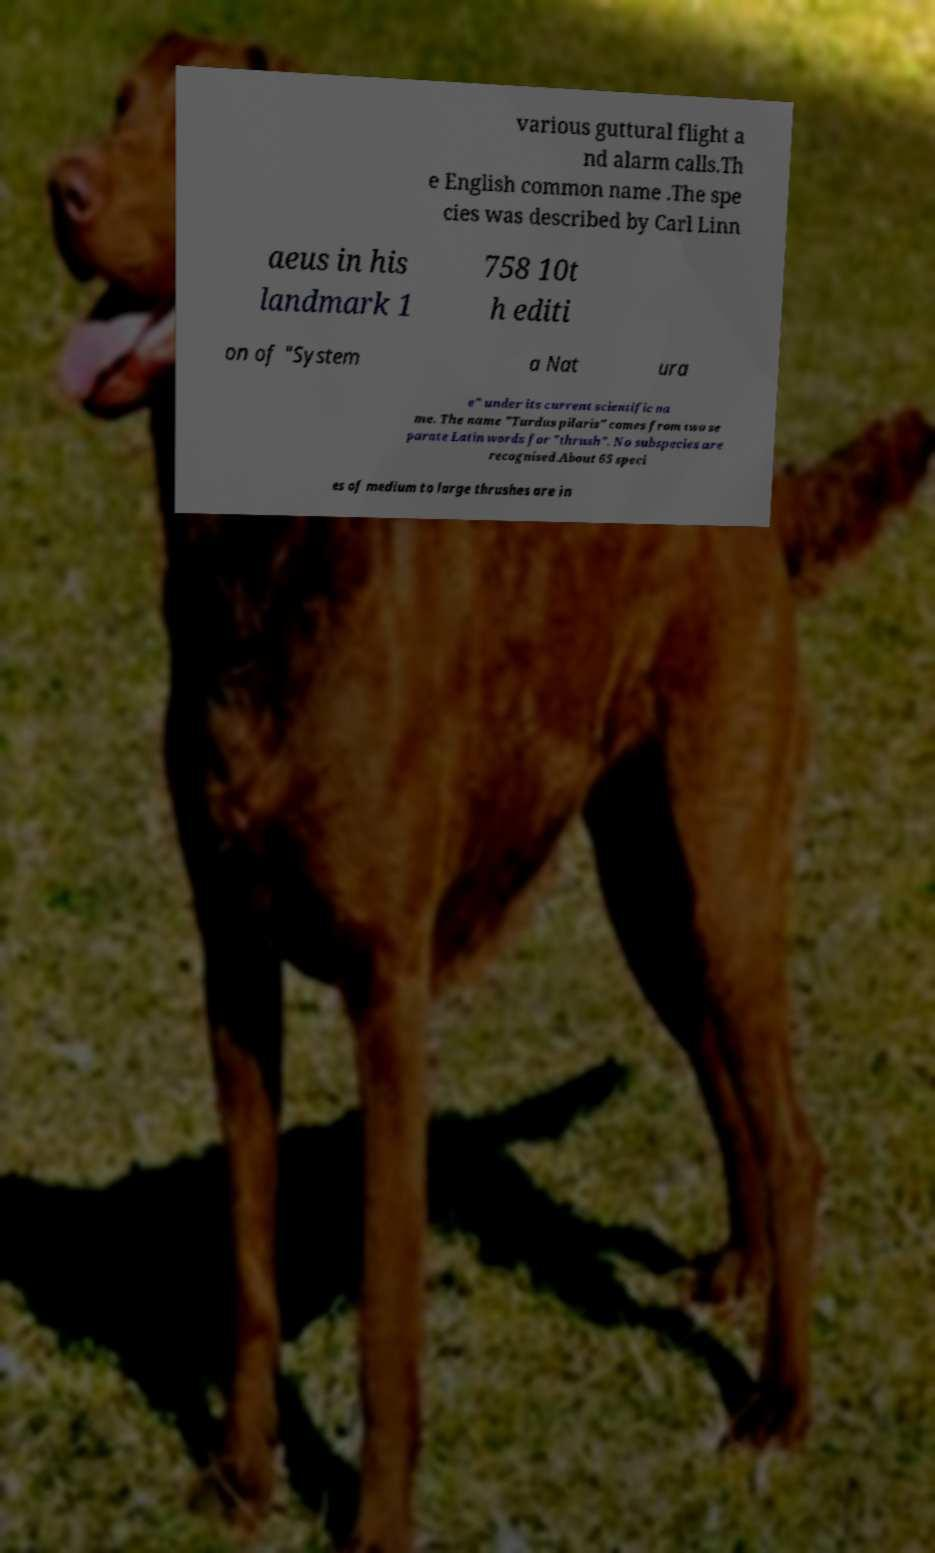I need the written content from this picture converted into text. Can you do that? various guttural flight a nd alarm calls.Th e English common name .The spe cies was described by Carl Linn aeus in his landmark 1 758 10t h editi on of "System a Nat ura e" under its current scientific na me. The name "Turdus pilaris" comes from two se parate Latin words for "thrush". No subspecies are recognised.About 65 speci es of medium to large thrushes are in 